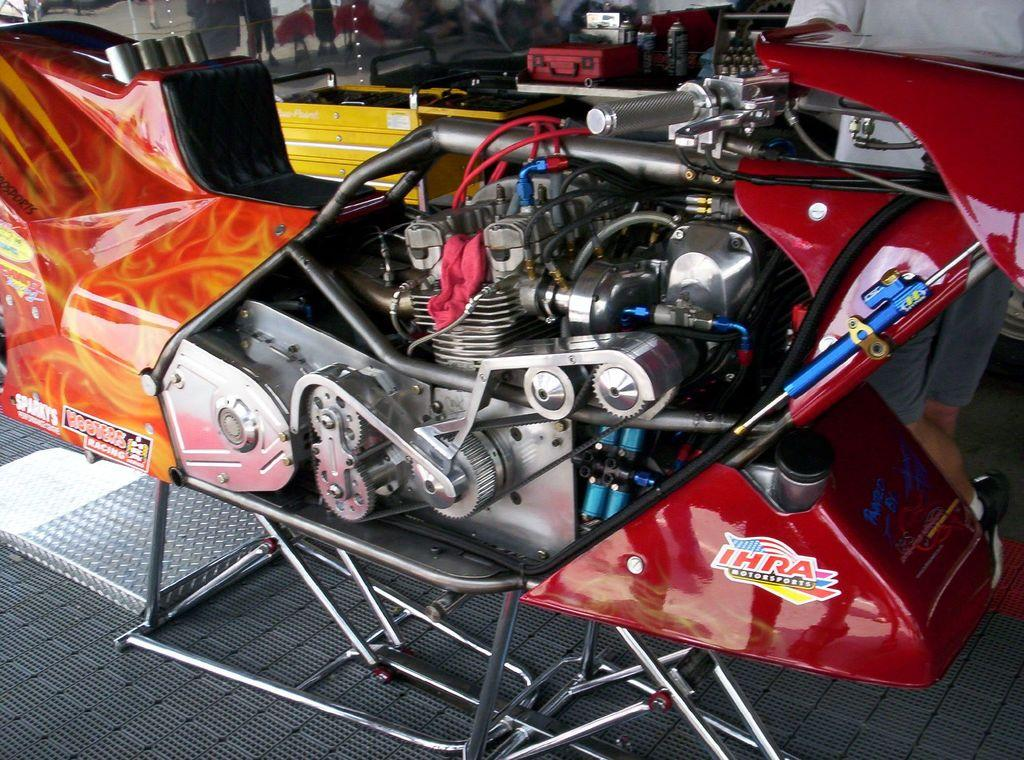What type of vehicle is in the image? There is a bike in the image. What is unique about this bike? The bike has an engine. What else can be seen in the image besides the bike? There are toolboxes in the image. What type of shirt is hanging in the cellar in the image? There is no shirt or cellar present in the image. What force is being applied to the bike in the image? There is no force being applied to the bike in the image; it is stationary. 